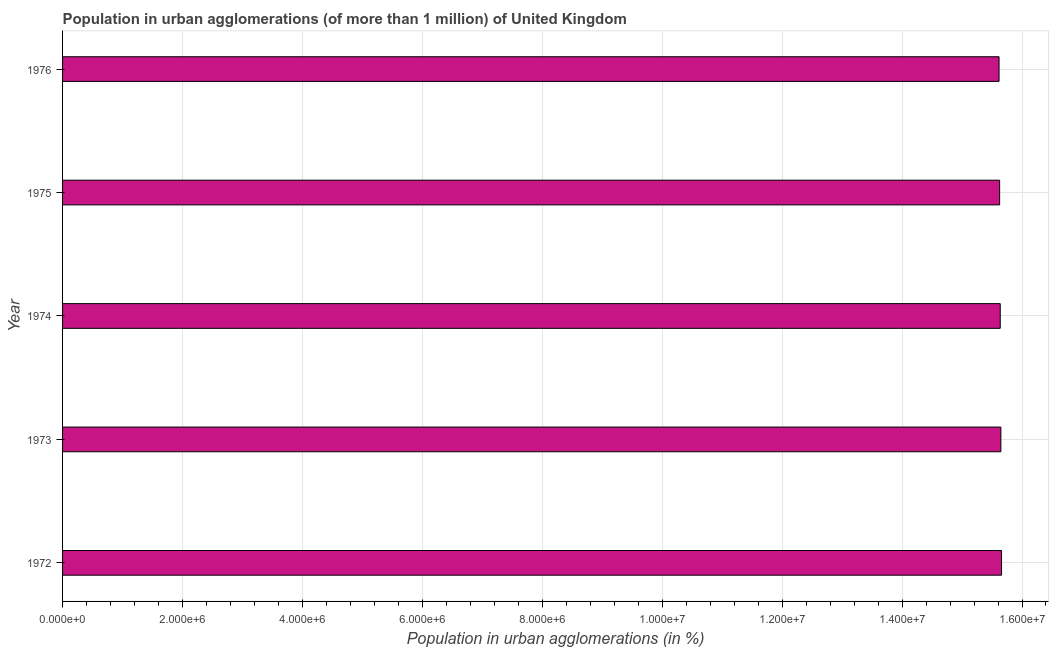What is the title of the graph?
Provide a short and direct response. Population in urban agglomerations (of more than 1 million) of United Kingdom. What is the label or title of the X-axis?
Provide a succinct answer. Population in urban agglomerations (in %). What is the population in urban agglomerations in 1976?
Your response must be concise. 1.56e+07. Across all years, what is the maximum population in urban agglomerations?
Your answer should be very brief. 1.57e+07. Across all years, what is the minimum population in urban agglomerations?
Provide a short and direct response. 1.56e+07. In which year was the population in urban agglomerations maximum?
Offer a terse response. 1972. In which year was the population in urban agglomerations minimum?
Your answer should be compact. 1976. What is the sum of the population in urban agglomerations?
Your answer should be very brief. 7.82e+07. What is the difference between the population in urban agglomerations in 1973 and 1975?
Your answer should be compact. 2.07e+04. What is the average population in urban agglomerations per year?
Your response must be concise. 1.56e+07. What is the median population in urban agglomerations?
Ensure brevity in your answer.  1.56e+07. In how many years, is the population in urban agglomerations greater than 4800000 %?
Offer a terse response. 5. What is the ratio of the population in urban agglomerations in 1973 to that in 1975?
Offer a terse response. 1. Is the population in urban agglomerations in 1972 less than that in 1973?
Offer a very short reply. No. What is the difference between the highest and the second highest population in urban agglomerations?
Keep it short and to the point. 1.11e+04. Is the sum of the population in urban agglomerations in 1972 and 1975 greater than the maximum population in urban agglomerations across all years?
Keep it short and to the point. Yes. What is the difference between the highest and the lowest population in urban agglomerations?
Ensure brevity in your answer.  4.15e+04. What is the difference between two consecutive major ticks on the X-axis?
Provide a short and direct response. 2.00e+06. What is the Population in urban agglomerations (in %) of 1972?
Your response must be concise. 1.57e+07. What is the Population in urban agglomerations (in %) in 1973?
Keep it short and to the point. 1.56e+07. What is the Population in urban agglomerations (in %) of 1974?
Offer a terse response. 1.56e+07. What is the Population in urban agglomerations (in %) in 1975?
Make the answer very short. 1.56e+07. What is the Population in urban agglomerations (in %) in 1976?
Your response must be concise. 1.56e+07. What is the difference between the Population in urban agglomerations (in %) in 1972 and 1973?
Your response must be concise. 1.11e+04. What is the difference between the Population in urban agglomerations (in %) in 1972 and 1974?
Keep it short and to the point. 2.17e+04. What is the difference between the Population in urban agglomerations (in %) in 1972 and 1975?
Offer a terse response. 3.18e+04. What is the difference between the Population in urban agglomerations (in %) in 1972 and 1976?
Give a very brief answer. 4.15e+04. What is the difference between the Population in urban agglomerations (in %) in 1973 and 1974?
Your response must be concise. 1.06e+04. What is the difference between the Population in urban agglomerations (in %) in 1973 and 1975?
Offer a very short reply. 2.07e+04. What is the difference between the Population in urban agglomerations (in %) in 1973 and 1976?
Make the answer very short. 3.04e+04. What is the difference between the Population in urban agglomerations (in %) in 1974 and 1975?
Provide a succinct answer. 1.01e+04. What is the difference between the Population in urban agglomerations (in %) in 1974 and 1976?
Keep it short and to the point. 1.98e+04. What is the difference between the Population in urban agglomerations (in %) in 1975 and 1976?
Keep it short and to the point. 9662. What is the ratio of the Population in urban agglomerations (in %) in 1973 to that in 1974?
Provide a short and direct response. 1. What is the ratio of the Population in urban agglomerations (in %) in 1973 to that in 1975?
Your answer should be compact. 1. What is the ratio of the Population in urban agglomerations (in %) in 1973 to that in 1976?
Provide a succinct answer. 1. What is the ratio of the Population in urban agglomerations (in %) in 1974 to that in 1975?
Your answer should be very brief. 1. What is the ratio of the Population in urban agglomerations (in %) in 1975 to that in 1976?
Your answer should be very brief. 1. 